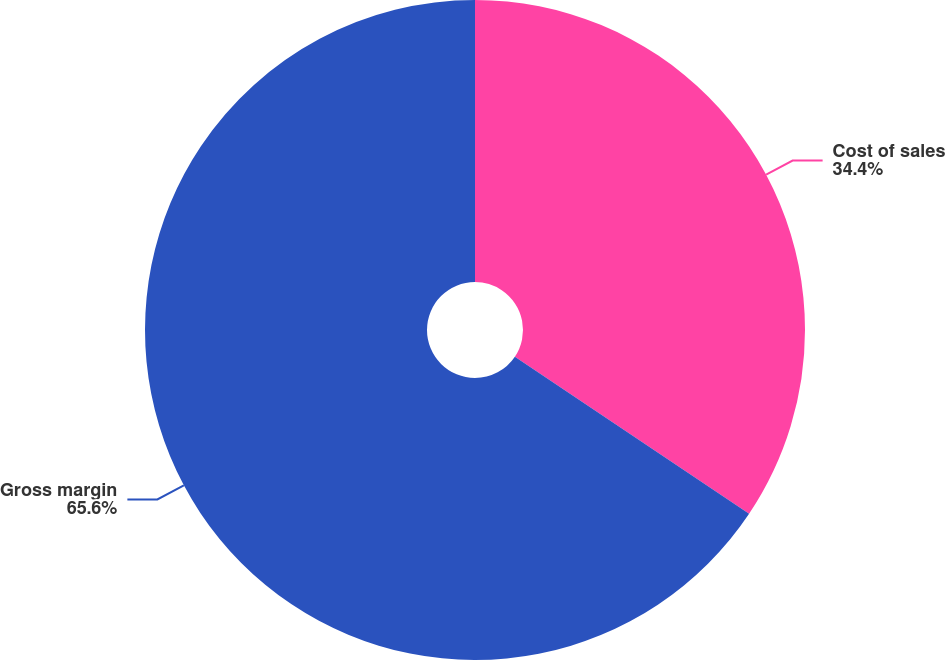<chart> <loc_0><loc_0><loc_500><loc_500><pie_chart><fcel>Cost of sales<fcel>Gross margin<nl><fcel>34.4%<fcel>65.6%<nl></chart> 